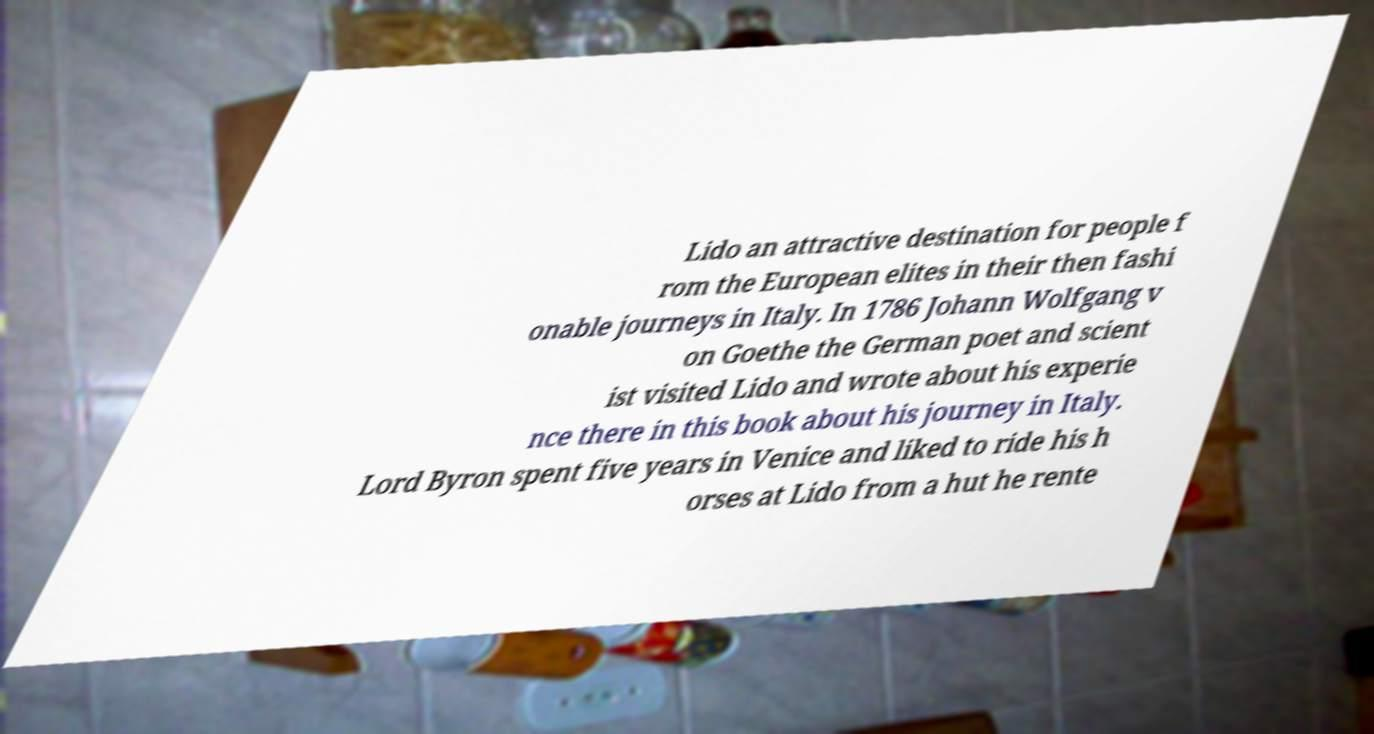Could you assist in decoding the text presented in this image and type it out clearly? Lido an attractive destination for people f rom the European elites in their then fashi onable journeys in Italy. In 1786 Johann Wolfgang v on Goethe the German poet and scient ist visited Lido and wrote about his experie nce there in this book about his journey in Italy. Lord Byron spent five years in Venice and liked to ride his h orses at Lido from a hut he rente 